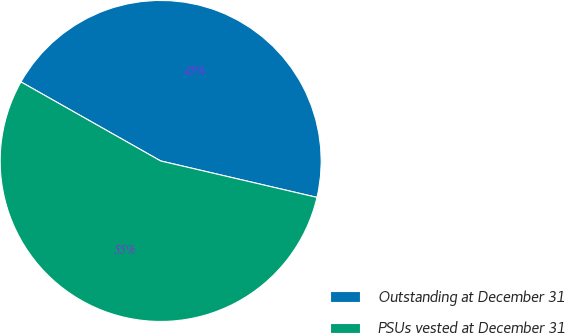<chart> <loc_0><loc_0><loc_500><loc_500><pie_chart><fcel>Outstanding at December 31<fcel>PSUs vested at December 31<nl><fcel>45.45%<fcel>54.55%<nl></chart> 